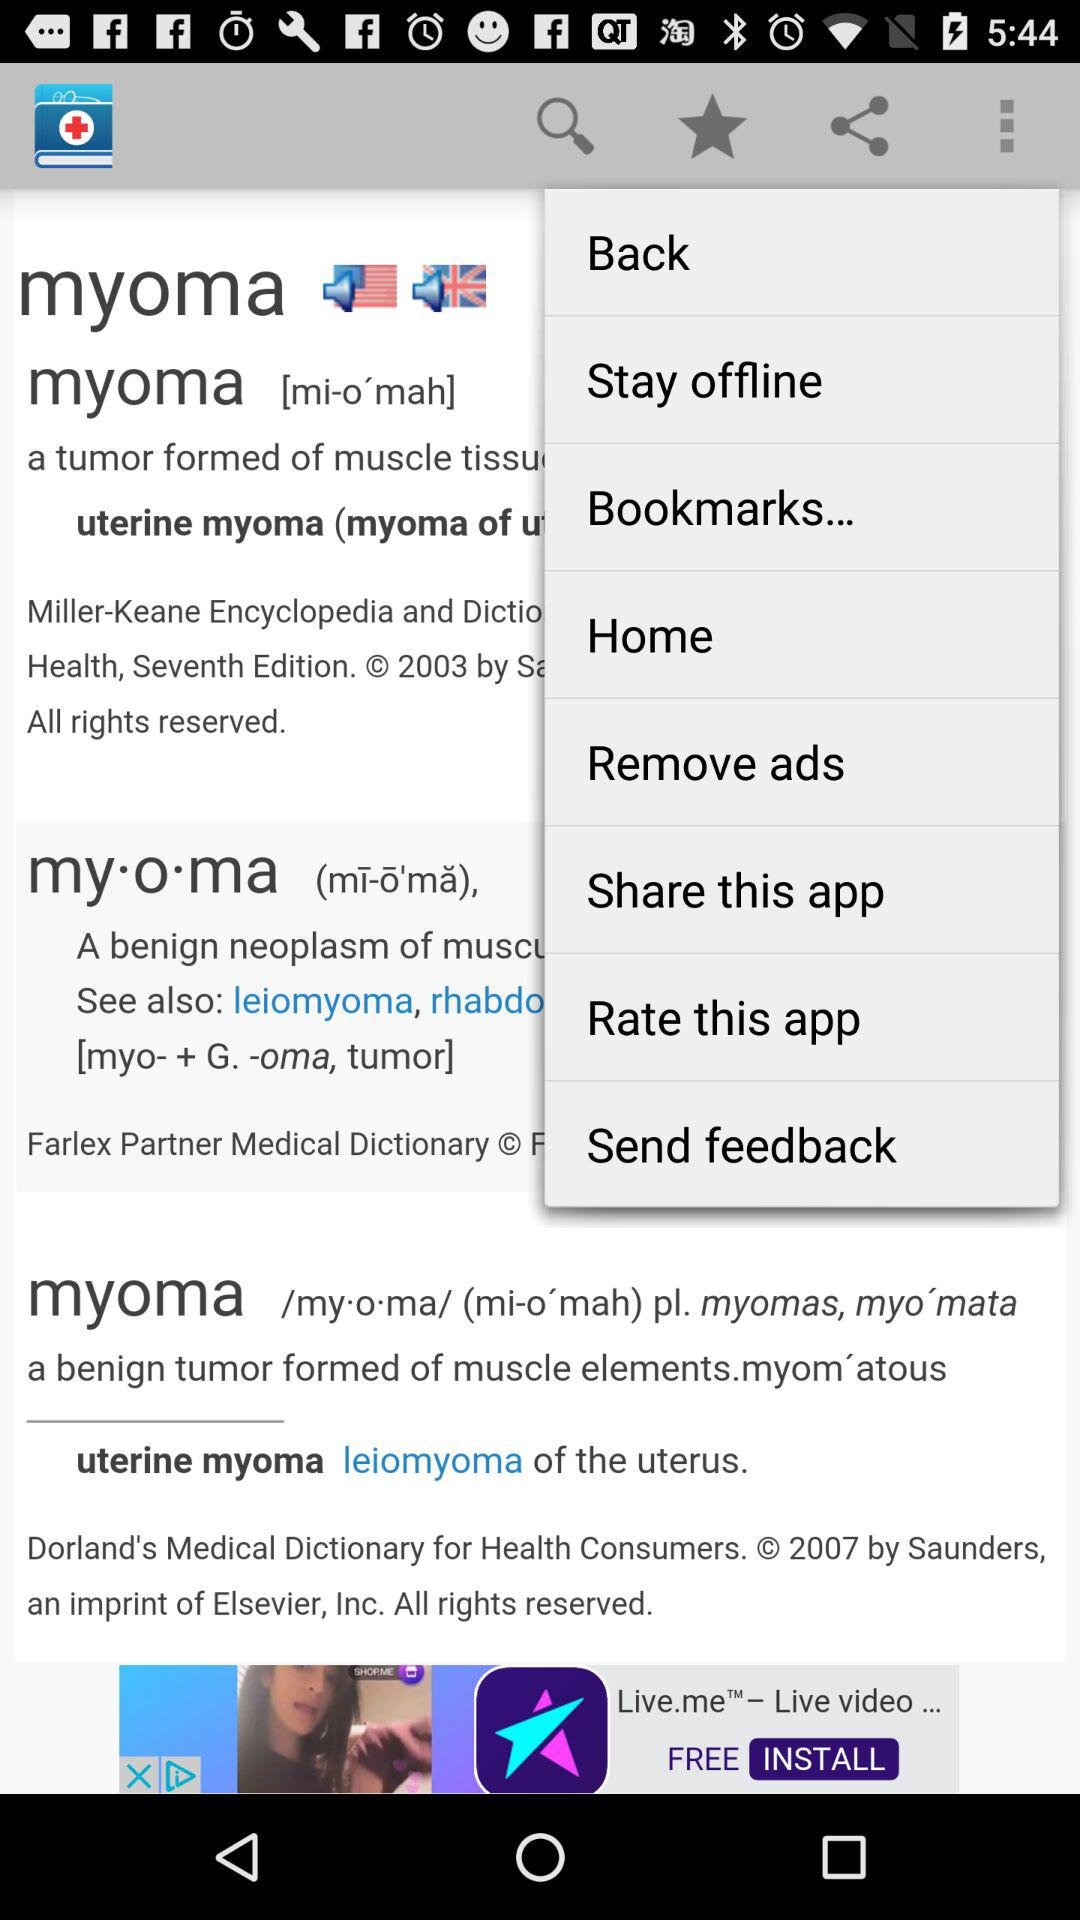How many flags are on the screen?
Answer the question using a single word or phrase. 2 